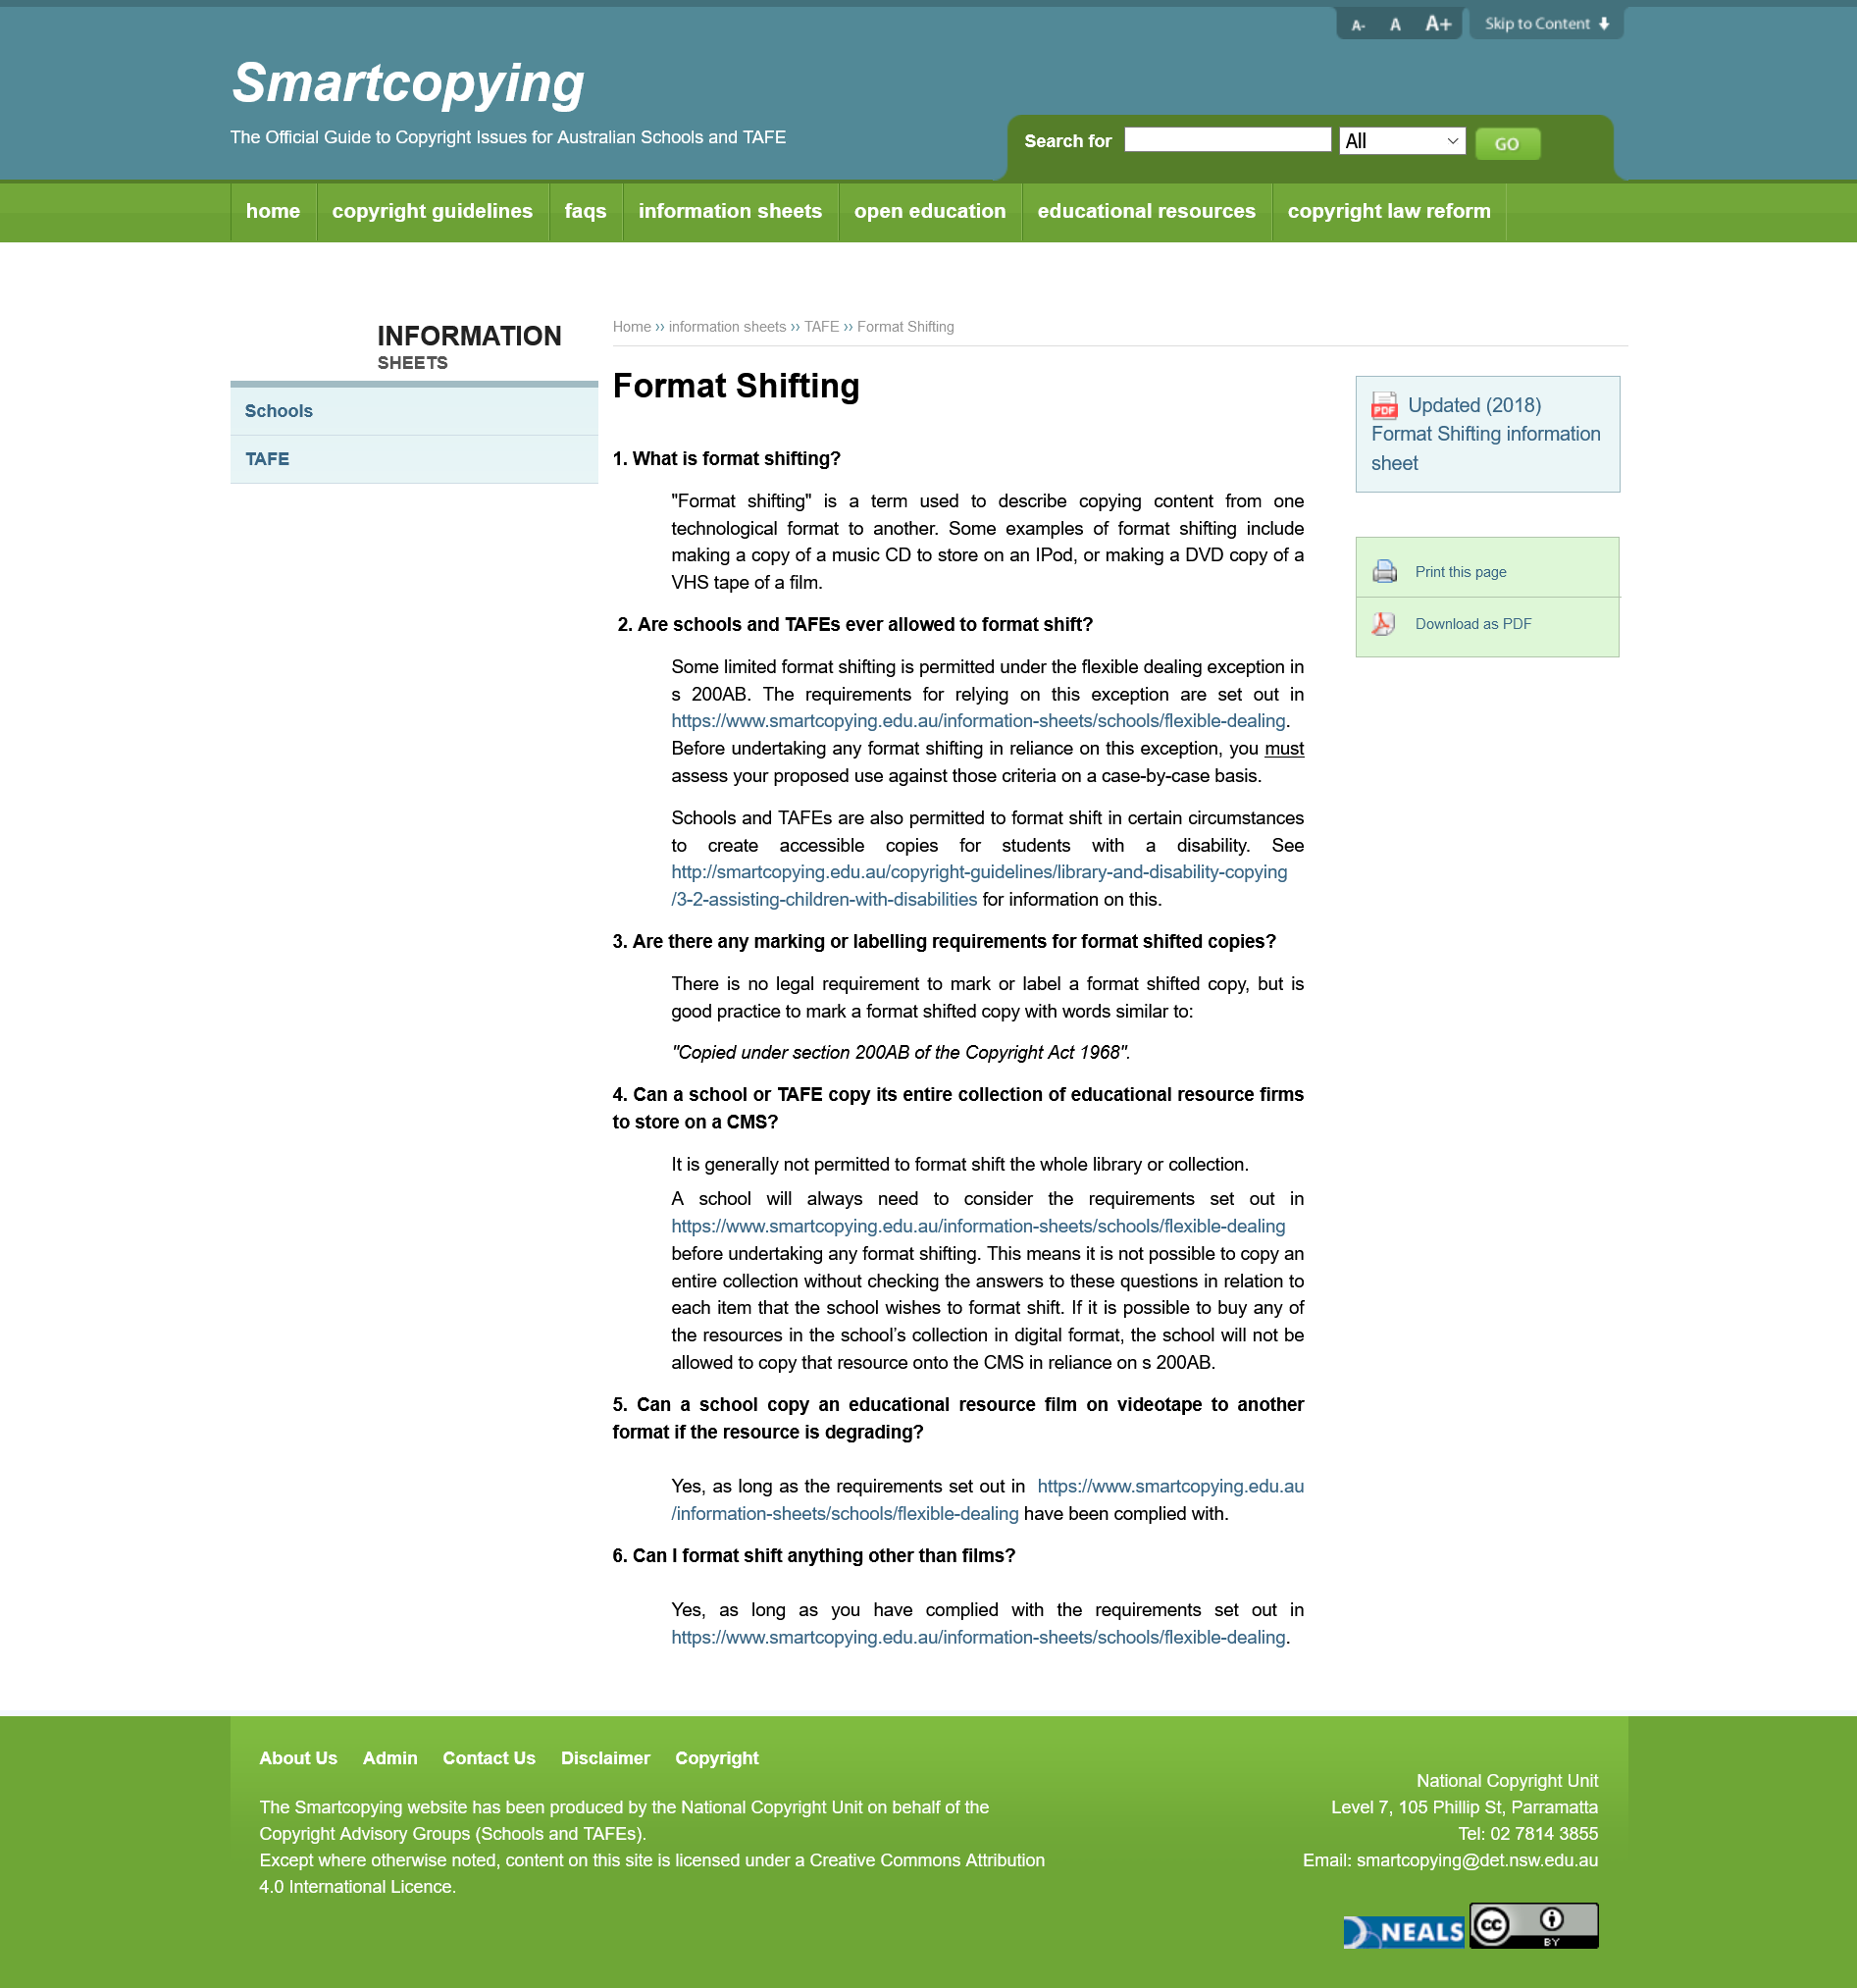Outline some significant characteristics in this image. It is not possible for a school to format a library or collection without first considering the answers to specific questions that apply to each individual item within the collection. The act of making a copy of a music CD to store on an IPod, commonly referred to as format shifting, constitutes a copyright infringement. Schools are permitted to format shift texts under the flexible dealing exception in section 200AB of the Copyright Act. It is a good practice to mark a format shifted copy with the words "Copied under section 200AB of the Copyright Act 1968" to indicate that the copy is a format shifted copy as defined by the Act. Format shifting refers to the act of copying content from one technological form to another, as defined in the law. 